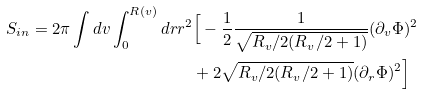Convert formula to latex. <formula><loc_0><loc_0><loc_500><loc_500>S _ { i n } = 2 \pi \int d v \int _ { 0 } ^ { R ( v ) } d r r ^ { 2 } & \Big { [ } - \frac { 1 } { 2 } \frac { 1 } { \sqrt { R _ { v } / 2 ( R _ { v } / 2 + 1 ) } } ( \partial _ { v } \Phi ) ^ { 2 } \\ & + 2 \sqrt { R _ { v } / 2 ( R _ { v } / 2 + 1 ) } ( \partial _ { r } \Phi ) ^ { 2 } \Big { ] }</formula> 